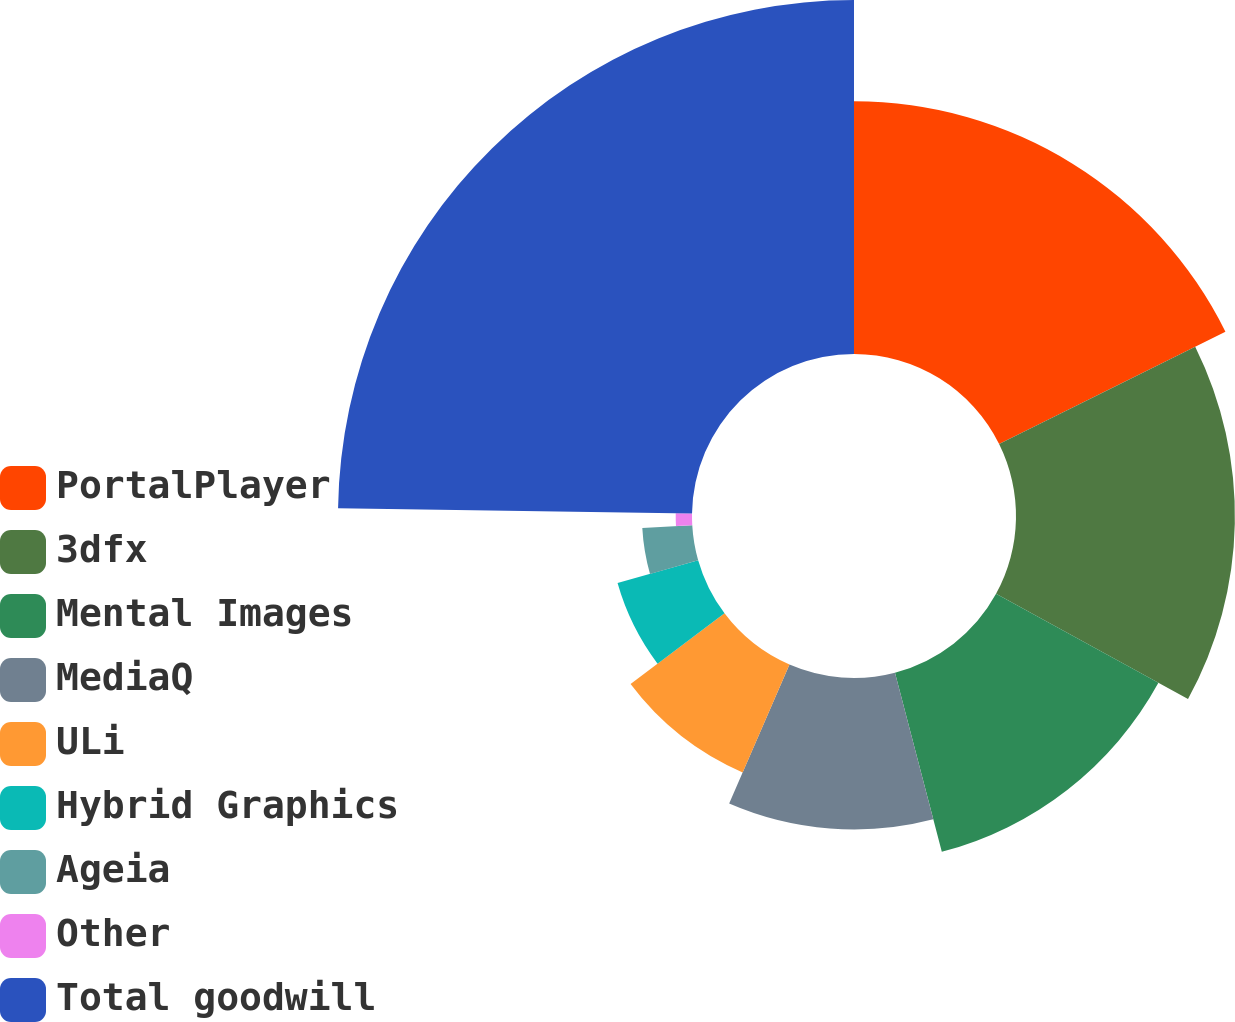<chart> <loc_0><loc_0><loc_500><loc_500><pie_chart><fcel>PortalPlayer<fcel>3dfx<fcel>Mental Images<fcel>MediaQ<fcel>ULi<fcel>Hybrid Graphics<fcel>Ageia<fcel>Other<fcel>Total goodwill<nl><fcel>17.67%<fcel>15.31%<fcel>12.95%<fcel>10.59%<fcel>8.22%<fcel>5.86%<fcel>3.5%<fcel>1.14%<fcel>24.76%<nl></chart> 